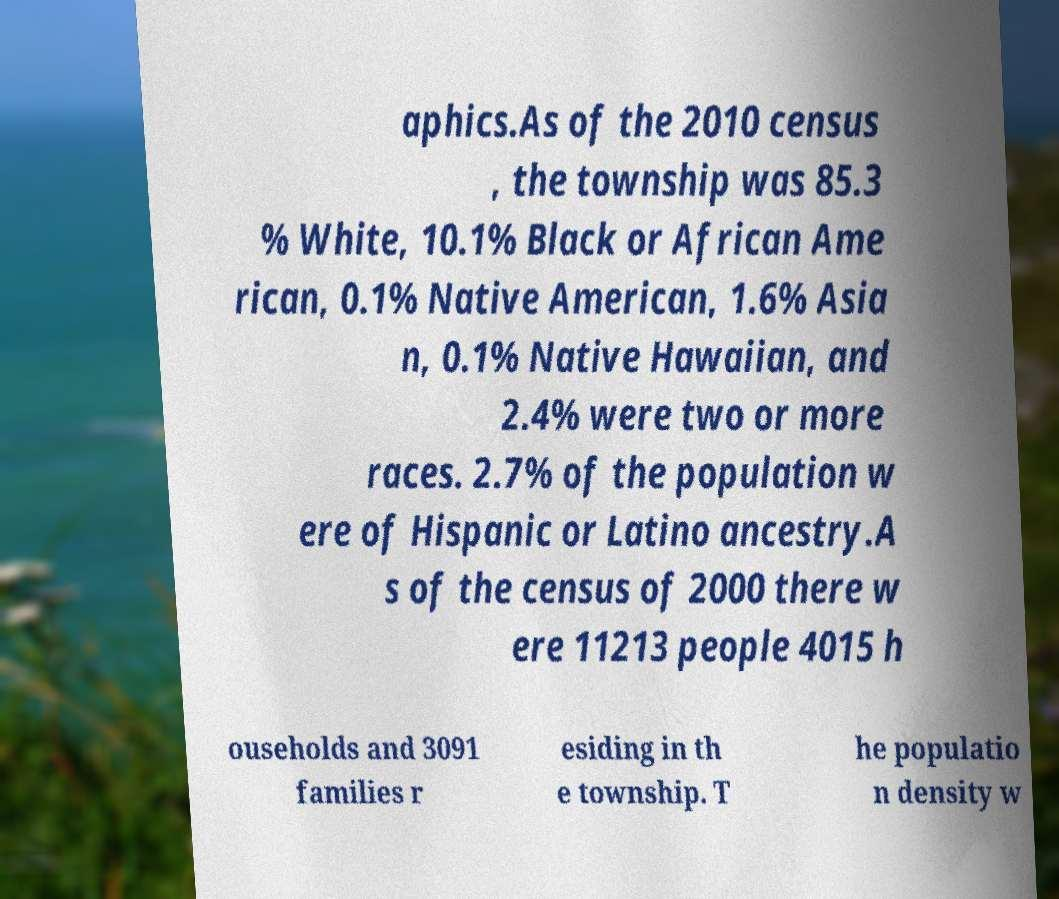Please identify and transcribe the text found in this image. aphics.As of the 2010 census , the township was 85.3 % White, 10.1% Black or African Ame rican, 0.1% Native American, 1.6% Asia n, 0.1% Native Hawaiian, and 2.4% were two or more races. 2.7% of the population w ere of Hispanic or Latino ancestry.A s of the census of 2000 there w ere 11213 people 4015 h ouseholds and 3091 families r esiding in th e township. T he populatio n density w 